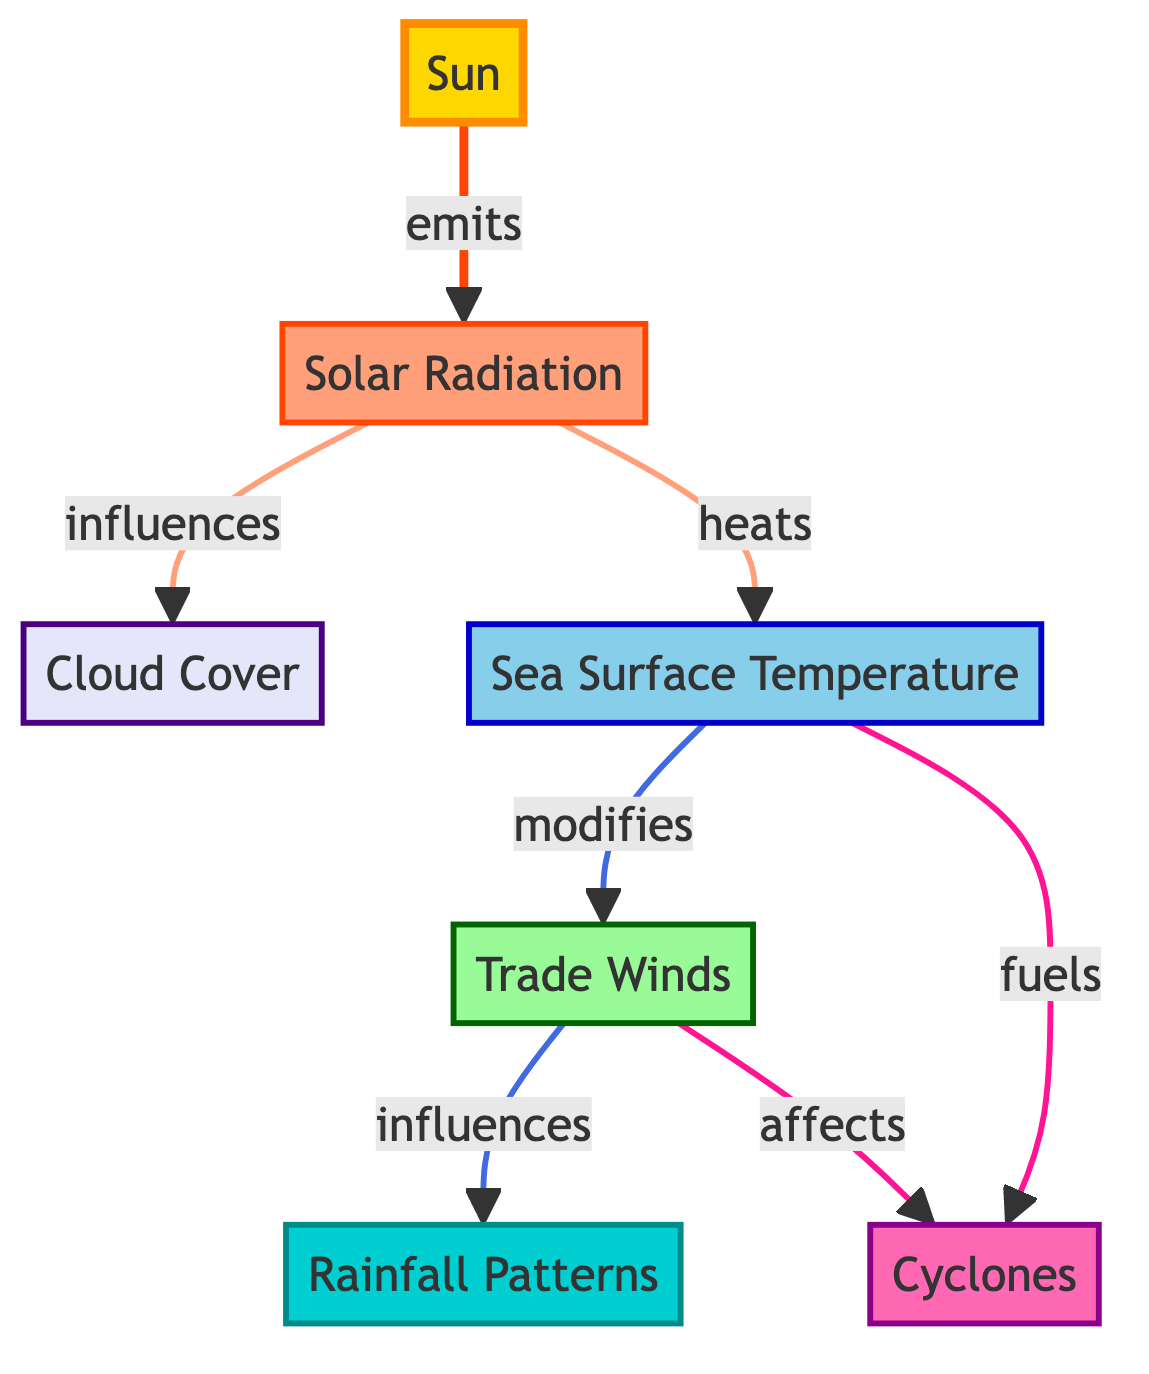What is the main source of energy for Niue's weather patterns? The diagram indicates that the "Sun" is the starting point and main source, as it emits energy that influences various components of weather patterns.
Answer: Sun Which component is influenced by solar radiation? The diagram shows a direct arrow from "Solar Radiation" pointing to "Cloud Cover," indicating that cloud cover is affected by solar radiation.
Answer: Cloud Cover What temperature factor influences trade winds? "Sea Surface Temperature" is indicated to modify the trade winds, as seen in the connection between these two components in the diagram.
Answer: Sea Surface Temperature How many main components are identified in the diagram? Counting the components listed in the diagram, there are a total of seven main elements: Sun, Solar Radiation, Cloud Cover, Sea Surface Temperature, Trade Winds, Rainfall Patterns, and Cyclones.
Answer: Seven What does sea surface temperature do to cyclones? The diagram states that "Sea Surface Temperature" fuels cyclones, demonstrating the relationship between the two.
Answer: Fuels How do trade winds affect rainfall patterns? The flow in the diagram illustrates that trade winds influence rainfall patterns, highlighting their impact on this weather factor.
Answer: Influences What element modifies the sea surface temperature? According to the diagram, solar radiation is indicated to heat the sea surface temperature, thereby modifying it.
Answer: Solar Radiation Which two components directly link to cyclones? The diagram shows that both "Sea Surface Temperature" and "Trade Winds" affect cyclones, creating a direct connection to these two elements.
Answer: Sea Surface Temperature and Trade Winds How does solar radiation affect cloud cover? The relationship is direct; the diagram indicates that solar radiation influences cloud cover, showing the dependency of clouds on solar energy.
Answer: Influences 